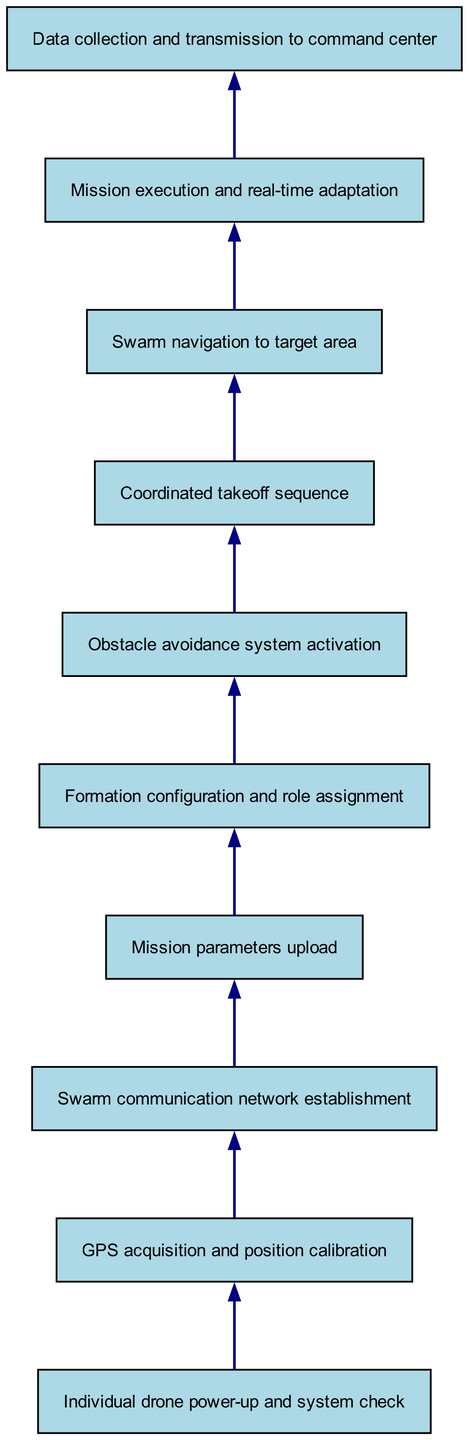What is the first step of the process? The first step of the process is represented by the first node, which states "Individual drone power-up and system check." This is clearly shown at the bottom of the flow chart as the starting point.
Answer: Individual drone power-up and system check How many total nodes are in the diagram? By counting each element listed in the data, there are 10 nodes present in the diagram, each representing a specific step in the process.
Answer: 10 What step comes after GPS acquisition and position calibration? Following the second node, "GPS acquisition and position calibration," the next step is connected, leading to "Swarm communication network establishment" shown in the third node.
Answer: Swarm communication network establishment What is the last step in the process? The final step, indicated at the top of the diagram, is "Data collection and transmission to command center," which shows the culmination of the process after all prior steps.
Answer: Data collection and transmission to command center Which step is immediately before the coordinated takeoff sequence? Before "Coordinated takeoff sequence," the diagram indicates that "Obstacle avoidance system activation" is the prior step, shown clearly in the sixth node.
Answer: Obstacle avoidance system activation How many connections are there in total? The connections between the nodes are represented by arrows, and adding up the connections from the data shows that there are 9 connections in total.
Answer: 9 What is the relationship between mission parameters upload and formation configuration? The flow indicates that after "Mission parameters upload," the next step directly connected is "Formation configuration and role assignment," indicating that the latter follows the former in succession.
Answer: Formation configuration and role assignment In which step is the obstacle avoidance system activated? The activation of the "Obstacle avoidance system" occurs during the sixth step of the process, as denoted by its position in the diagram.
Answer: Obstacle avoidance system activation How do drones navigate to the target area? Drones navigate to the target area in the eighth step, which is a definitive action following their coordinated takeoff, according to the flow of the diagram.
Answer: Swarm navigation to target area 